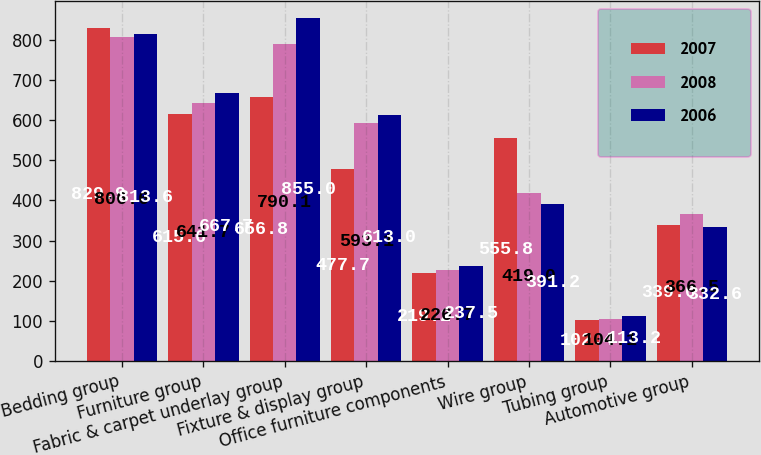Convert chart to OTSL. <chart><loc_0><loc_0><loc_500><loc_500><stacked_bar_chart><ecel><fcel>Bedding group<fcel>Furniture group<fcel>Fabric & carpet underlay group<fcel>Fixture & display group<fcel>Office furniture components<fcel>Wire group<fcel>Tubing group<fcel>Automotive group<nl><fcel>2007<fcel>829.9<fcel>615.6<fcel>656.8<fcel>477.7<fcel>219.2<fcel>555.8<fcel>102.4<fcel>339<nl><fcel>2008<fcel>806.6<fcel>641.7<fcel>790.1<fcel>593.1<fcel>226.7<fcel>419<fcel>104.1<fcel>366.5<nl><fcel>2006<fcel>813.6<fcel>667.7<fcel>855<fcel>613<fcel>237.5<fcel>391.2<fcel>113.2<fcel>332.6<nl></chart> 